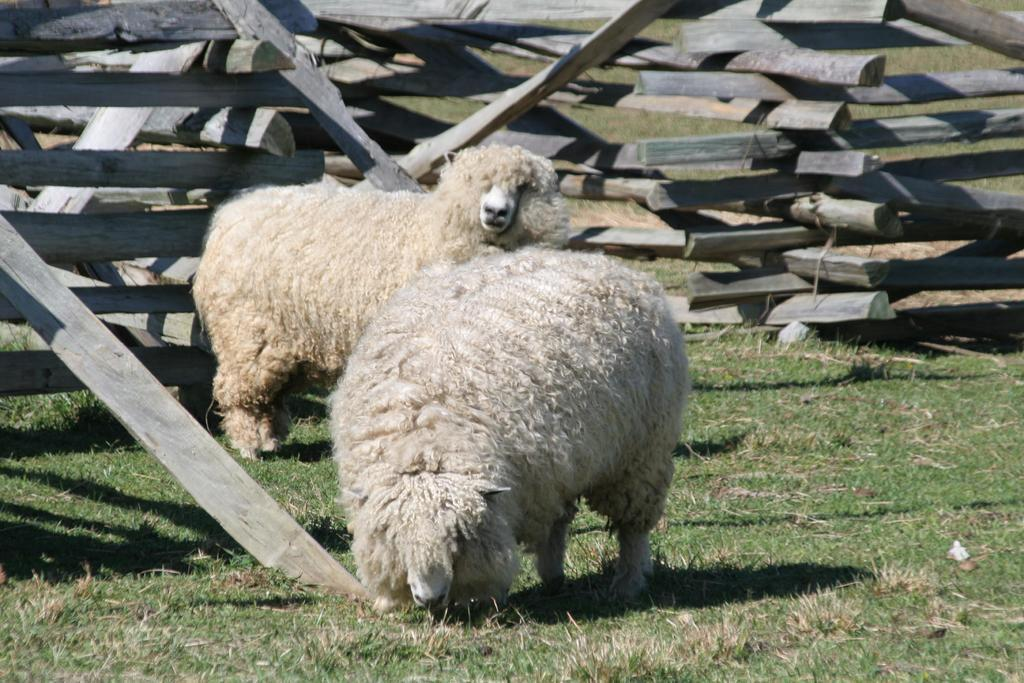How many animals are present in the image? There are two sheep in the image. What type of surface are the sheep standing on? The sheep are on the grass. What can be seen in the background of the image? There are wooden sticks arranged in the background of the image. What type of park can be seen in the background of the image? There is no park present in the image; it features two sheep on the grass with wooden sticks in the background. What is the sheep's brother doing in the image? There is no mention of a brother or any other sheep in the image. 